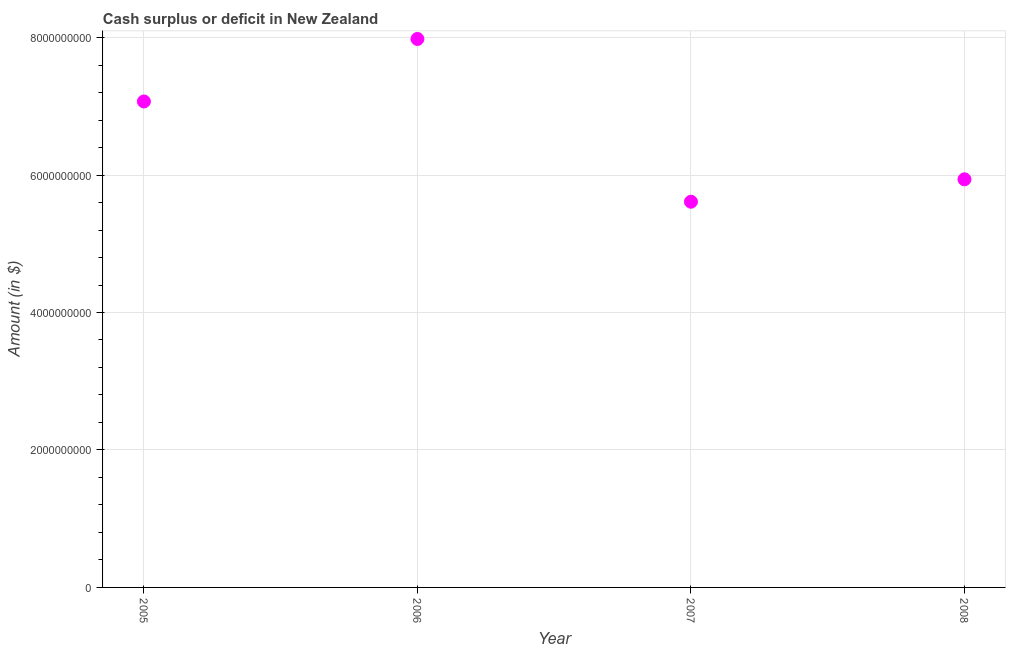What is the cash surplus or deficit in 2008?
Your answer should be compact. 5.94e+09. Across all years, what is the maximum cash surplus or deficit?
Your answer should be very brief. 7.98e+09. Across all years, what is the minimum cash surplus or deficit?
Your response must be concise. 5.61e+09. In which year was the cash surplus or deficit maximum?
Offer a very short reply. 2006. What is the sum of the cash surplus or deficit?
Your response must be concise. 2.66e+1. What is the difference between the cash surplus or deficit in 2006 and 2008?
Your response must be concise. 2.04e+09. What is the average cash surplus or deficit per year?
Make the answer very short. 6.65e+09. What is the median cash surplus or deficit?
Your answer should be very brief. 6.50e+09. What is the ratio of the cash surplus or deficit in 2007 to that in 2008?
Offer a very short reply. 0.95. Is the cash surplus or deficit in 2005 less than that in 2006?
Give a very brief answer. Yes. What is the difference between the highest and the second highest cash surplus or deficit?
Offer a very short reply. 9.09e+08. Is the sum of the cash surplus or deficit in 2005 and 2007 greater than the maximum cash surplus or deficit across all years?
Offer a terse response. Yes. What is the difference between the highest and the lowest cash surplus or deficit?
Offer a terse response. 2.37e+09. How many years are there in the graph?
Keep it short and to the point. 4. What is the difference between two consecutive major ticks on the Y-axis?
Your answer should be compact. 2.00e+09. Does the graph contain any zero values?
Your response must be concise. No. What is the title of the graph?
Provide a succinct answer. Cash surplus or deficit in New Zealand. What is the label or title of the Y-axis?
Offer a terse response. Amount (in $). What is the Amount (in $) in 2005?
Your answer should be compact. 7.07e+09. What is the Amount (in $) in 2006?
Your answer should be very brief. 7.98e+09. What is the Amount (in $) in 2007?
Provide a succinct answer. 5.61e+09. What is the Amount (in $) in 2008?
Your response must be concise. 5.94e+09. What is the difference between the Amount (in $) in 2005 and 2006?
Ensure brevity in your answer.  -9.09e+08. What is the difference between the Amount (in $) in 2005 and 2007?
Provide a short and direct response. 1.46e+09. What is the difference between the Amount (in $) in 2005 and 2008?
Provide a short and direct response. 1.13e+09. What is the difference between the Amount (in $) in 2006 and 2007?
Your answer should be compact. 2.37e+09. What is the difference between the Amount (in $) in 2006 and 2008?
Keep it short and to the point. 2.04e+09. What is the difference between the Amount (in $) in 2007 and 2008?
Ensure brevity in your answer.  -3.26e+08. What is the ratio of the Amount (in $) in 2005 to that in 2006?
Offer a terse response. 0.89. What is the ratio of the Amount (in $) in 2005 to that in 2007?
Offer a very short reply. 1.26. What is the ratio of the Amount (in $) in 2005 to that in 2008?
Your response must be concise. 1.19. What is the ratio of the Amount (in $) in 2006 to that in 2007?
Keep it short and to the point. 1.42. What is the ratio of the Amount (in $) in 2006 to that in 2008?
Provide a succinct answer. 1.34. What is the ratio of the Amount (in $) in 2007 to that in 2008?
Make the answer very short. 0.94. 